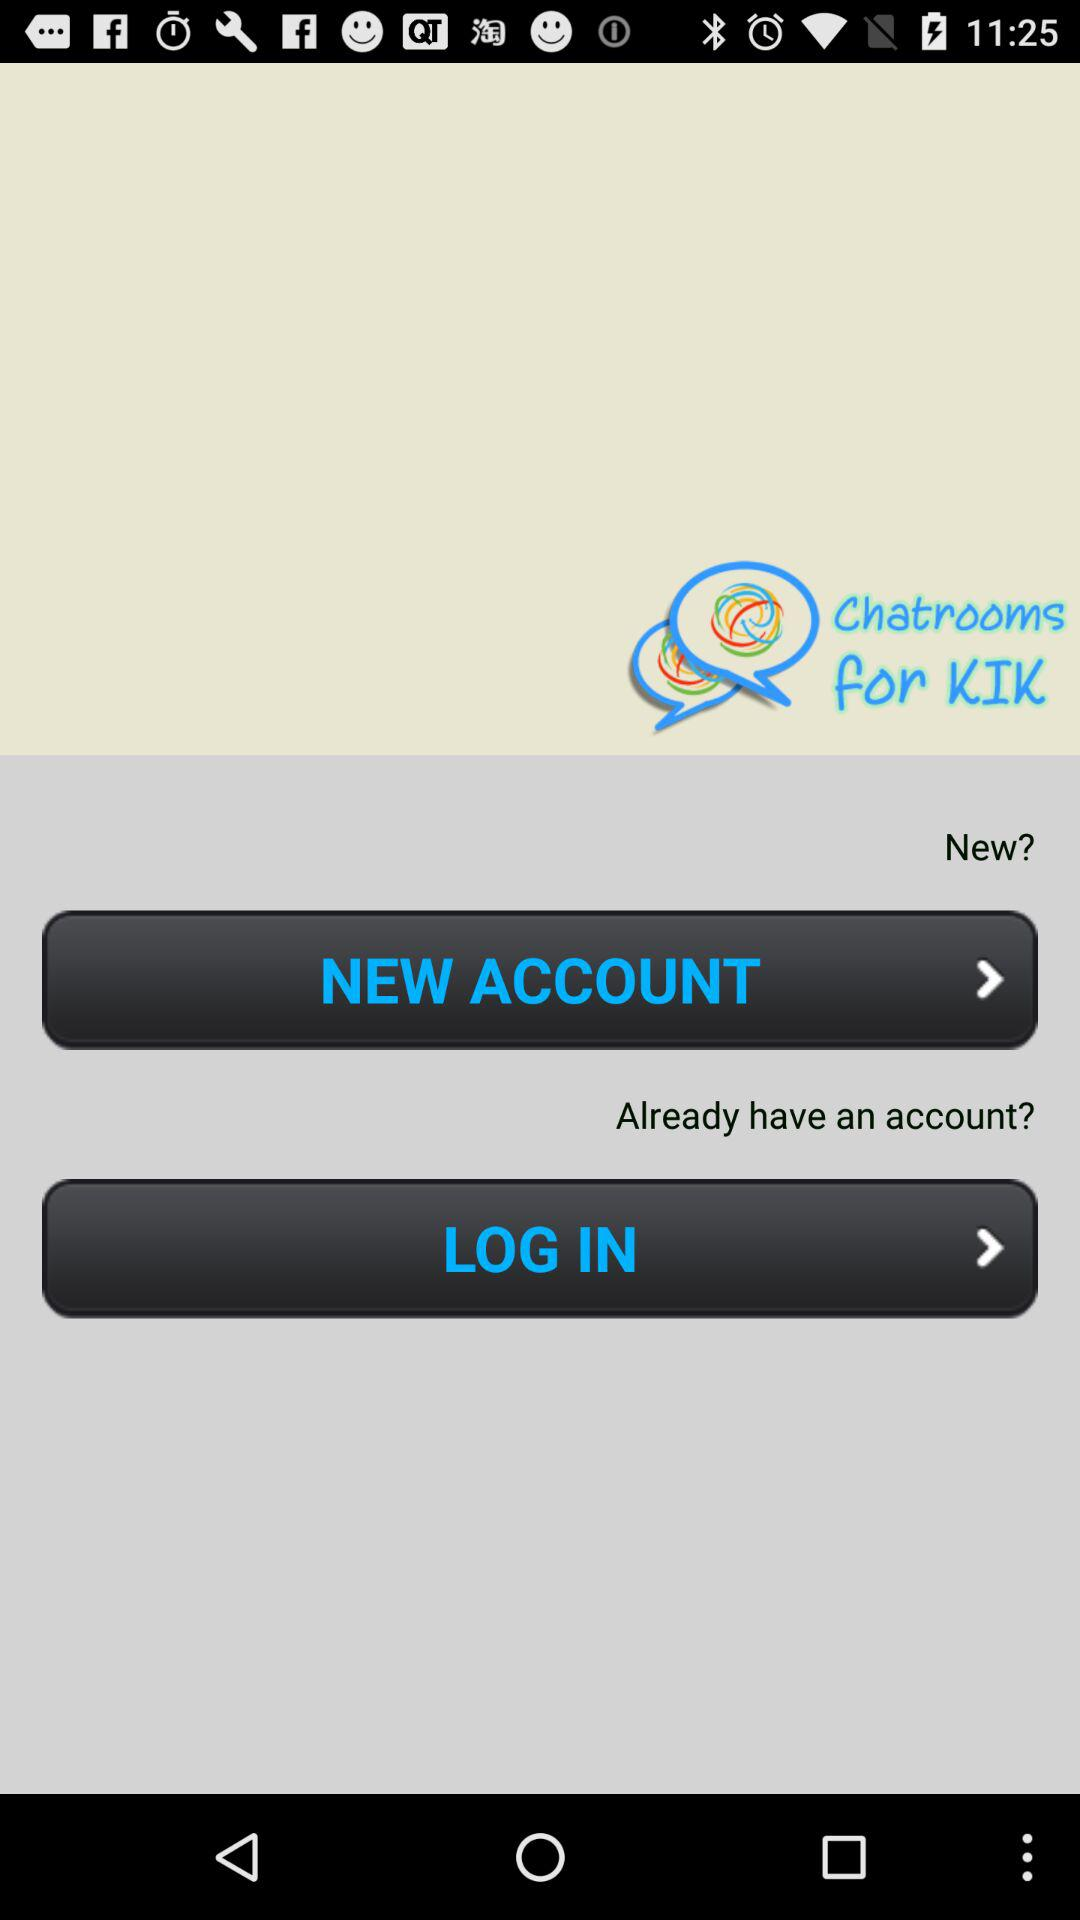What is the name of application? The name of the application is "Chatrooms for KIK". 